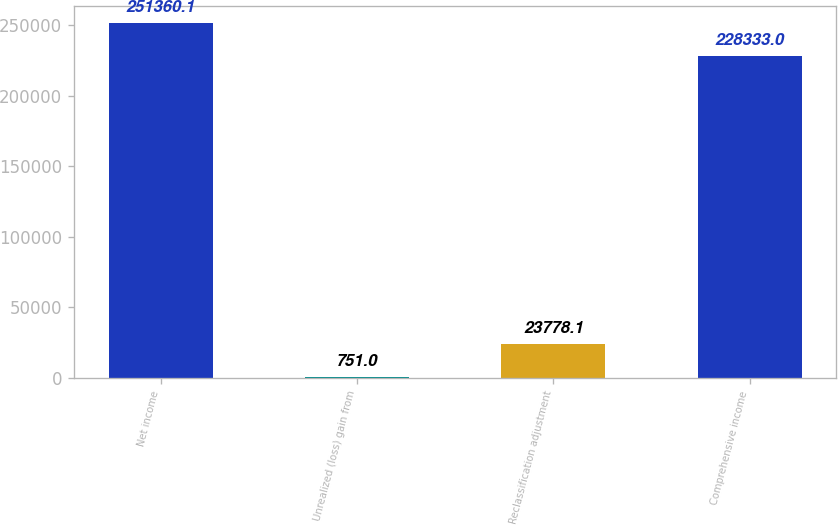<chart> <loc_0><loc_0><loc_500><loc_500><bar_chart><fcel>Net income<fcel>Unrealized (loss) gain from<fcel>Reclassification adjustment<fcel>Comprehensive income<nl><fcel>251360<fcel>751<fcel>23778.1<fcel>228333<nl></chart> 